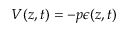Convert formula to latex. <formula><loc_0><loc_0><loc_500><loc_500>V ( z , t ) = - p \epsilon ( z , t )</formula> 